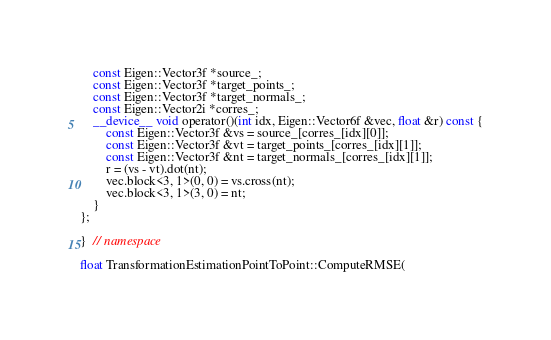<code> <loc_0><loc_0><loc_500><loc_500><_Cuda_>    const Eigen::Vector3f *source_;
    const Eigen::Vector3f *target_points_;
    const Eigen::Vector3f *target_normals_;
    const Eigen::Vector2i *corres_;
    __device__ void operator()(int idx, Eigen::Vector6f &vec, float &r) const {
        const Eigen::Vector3f &vs = source_[corres_[idx][0]];
        const Eigen::Vector3f &vt = target_points_[corres_[idx][1]];
        const Eigen::Vector3f &nt = target_normals_[corres_[idx][1]];
        r = (vs - vt).dot(nt);
        vec.block<3, 1>(0, 0) = vs.cross(nt);
        vec.block<3, 1>(3, 0) = nt;
    }
};

}  // namespace

float TransformationEstimationPointToPoint::ComputeRMSE(</code> 